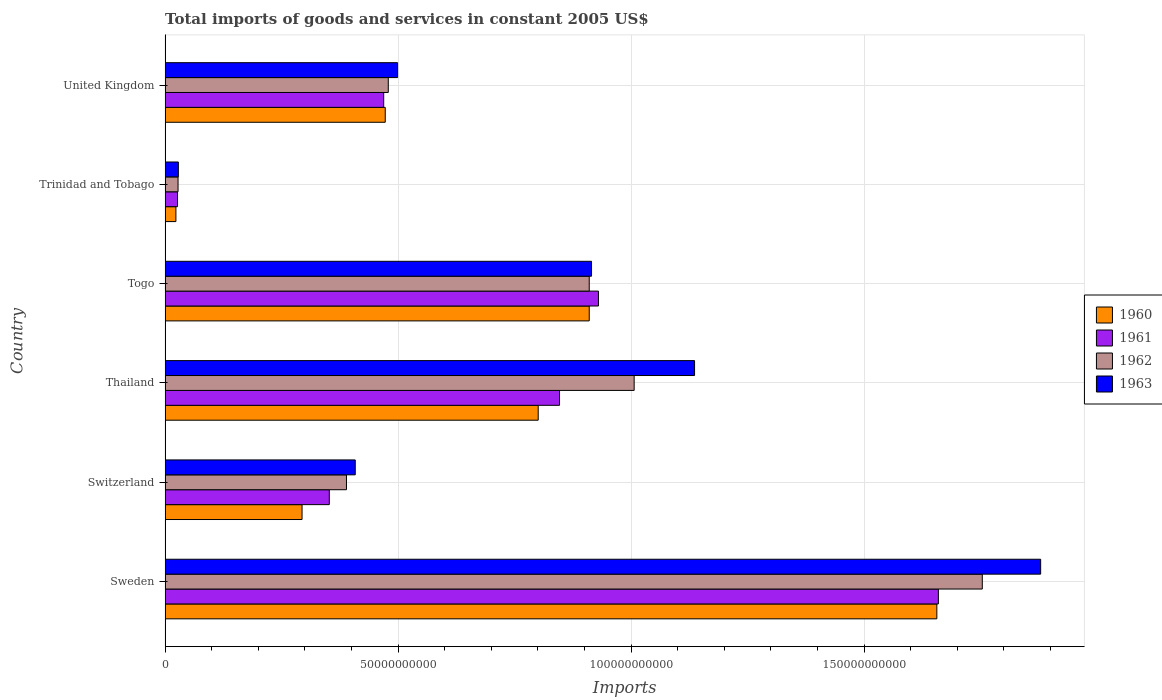How many groups of bars are there?
Offer a terse response. 6. How many bars are there on the 4th tick from the bottom?
Offer a very short reply. 4. What is the label of the 3rd group of bars from the top?
Your answer should be very brief. Togo. In how many cases, is the number of bars for a given country not equal to the number of legend labels?
Your response must be concise. 0. What is the total imports of goods and services in 1961 in Switzerland?
Keep it short and to the point. 3.52e+1. Across all countries, what is the maximum total imports of goods and services in 1963?
Offer a very short reply. 1.88e+11. Across all countries, what is the minimum total imports of goods and services in 1962?
Make the answer very short. 2.78e+09. In which country was the total imports of goods and services in 1960 minimum?
Provide a succinct answer. Trinidad and Tobago. What is the total total imports of goods and services in 1963 in the graph?
Your response must be concise. 4.87e+11. What is the difference between the total imports of goods and services in 1960 in Switzerland and that in Togo?
Provide a short and direct response. -6.16e+1. What is the difference between the total imports of goods and services in 1962 in Thailand and the total imports of goods and services in 1961 in United Kingdom?
Your response must be concise. 5.37e+1. What is the average total imports of goods and services in 1961 per country?
Make the answer very short. 7.14e+1. What is the difference between the total imports of goods and services in 1960 and total imports of goods and services in 1962 in Thailand?
Your answer should be very brief. -2.06e+1. What is the ratio of the total imports of goods and services in 1960 in Switzerland to that in United Kingdom?
Provide a short and direct response. 0.62. Is the difference between the total imports of goods and services in 1960 in Thailand and Trinidad and Tobago greater than the difference between the total imports of goods and services in 1962 in Thailand and Trinidad and Tobago?
Your response must be concise. No. What is the difference between the highest and the second highest total imports of goods and services in 1961?
Your response must be concise. 7.29e+1. What is the difference between the highest and the lowest total imports of goods and services in 1961?
Give a very brief answer. 1.63e+11. Is it the case that in every country, the sum of the total imports of goods and services in 1963 and total imports of goods and services in 1961 is greater than the sum of total imports of goods and services in 1960 and total imports of goods and services in 1962?
Offer a very short reply. No. What does the 2nd bar from the bottom in Togo represents?
Provide a short and direct response. 1961. Are all the bars in the graph horizontal?
Keep it short and to the point. Yes. Are the values on the major ticks of X-axis written in scientific E-notation?
Your answer should be very brief. No. Does the graph contain any zero values?
Make the answer very short. No. Does the graph contain grids?
Give a very brief answer. Yes. How are the legend labels stacked?
Provide a succinct answer. Vertical. What is the title of the graph?
Your answer should be very brief. Total imports of goods and services in constant 2005 US$. Does "1974" appear as one of the legend labels in the graph?
Make the answer very short. No. What is the label or title of the X-axis?
Your answer should be compact. Imports. What is the Imports of 1960 in Sweden?
Your answer should be compact. 1.66e+11. What is the Imports of 1961 in Sweden?
Your answer should be very brief. 1.66e+11. What is the Imports of 1962 in Sweden?
Provide a short and direct response. 1.75e+11. What is the Imports in 1963 in Sweden?
Keep it short and to the point. 1.88e+11. What is the Imports in 1960 in Switzerland?
Offer a very short reply. 2.94e+1. What is the Imports of 1961 in Switzerland?
Your answer should be compact. 3.52e+1. What is the Imports of 1962 in Switzerland?
Provide a succinct answer. 3.89e+1. What is the Imports in 1963 in Switzerland?
Keep it short and to the point. 4.08e+1. What is the Imports in 1960 in Thailand?
Your answer should be compact. 8.01e+1. What is the Imports of 1961 in Thailand?
Your answer should be compact. 8.46e+1. What is the Imports in 1962 in Thailand?
Give a very brief answer. 1.01e+11. What is the Imports in 1963 in Thailand?
Your answer should be very brief. 1.14e+11. What is the Imports in 1960 in Togo?
Provide a short and direct response. 9.10e+1. What is the Imports in 1961 in Togo?
Provide a succinct answer. 9.30e+1. What is the Imports in 1962 in Togo?
Make the answer very short. 9.10e+1. What is the Imports in 1963 in Togo?
Ensure brevity in your answer.  9.15e+1. What is the Imports of 1960 in Trinidad and Tobago?
Ensure brevity in your answer.  2.32e+09. What is the Imports in 1961 in Trinidad and Tobago?
Your response must be concise. 2.67e+09. What is the Imports in 1962 in Trinidad and Tobago?
Keep it short and to the point. 2.78e+09. What is the Imports in 1963 in Trinidad and Tobago?
Offer a terse response. 2.85e+09. What is the Imports of 1960 in United Kingdom?
Your response must be concise. 4.72e+1. What is the Imports in 1961 in United Kingdom?
Your response must be concise. 4.69e+1. What is the Imports in 1962 in United Kingdom?
Offer a terse response. 4.79e+1. What is the Imports in 1963 in United Kingdom?
Give a very brief answer. 4.99e+1. Across all countries, what is the maximum Imports of 1960?
Your response must be concise. 1.66e+11. Across all countries, what is the maximum Imports in 1961?
Offer a very short reply. 1.66e+11. Across all countries, what is the maximum Imports of 1962?
Provide a succinct answer. 1.75e+11. Across all countries, what is the maximum Imports in 1963?
Offer a terse response. 1.88e+11. Across all countries, what is the minimum Imports in 1960?
Provide a short and direct response. 2.32e+09. Across all countries, what is the minimum Imports of 1961?
Ensure brevity in your answer.  2.67e+09. Across all countries, what is the minimum Imports of 1962?
Offer a terse response. 2.78e+09. Across all countries, what is the minimum Imports in 1963?
Keep it short and to the point. 2.85e+09. What is the total Imports of 1960 in the graph?
Keep it short and to the point. 4.16e+11. What is the total Imports in 1961 in the graph?
Your answer should be compact. 4.28e+11. What is the total Imports in 1962 in the graph?
Give a very brief answer. 4.57e+11. What is the total Imports in 1963 in the graph?
Offer a terse response. 4.87e+11. What is the difference between the Imports of 1960 in Sweden and that in Switzerland?
Offer a very short reply. 1.36e+11. What is the difference between the Imports of 1961 in Sweden and that in Switzerland?
Provide a succinct answer. 1.31e+11. What is the difference between the Imports in 1962 in Sweden and that in Switzerland?
Offer a very short reply. 1.36e+11. What is the difference between the Imports of 1963 in Sweden and that in Switzerland?
Make the answer very short. 1.47e+11. What is the difference between the Imports of 1960 in Sweden and that in Thailand?
Offer a very short reply. 8.55e+1. What is the difference between the Imports in 1961 in Sweden and that in Thailand?
Offer a very short reply. 8.13e+1. What is the difference between the Imports in 1962 in Sweden and that in Thailand?
Keep it short and to the point. 7.47e+1. What is the difference between the Imports of 1963 in Sweden and that in Thailand?
Your answer should be compact. 7.43e+1. What is the difference between the Imports in 1960 in Sweden and that in Togo?
Offer a very short reply. 7.46e+1. What is the difference between the Imports of 1961 in Sweden and that in Togo?
Your answer should be compact. 7.29e+1. What is the difference between the Imports of 1962 in Sweden and that in Togo?
Keep it short and to the point. 8.44e+1. What is the difference between the Imports of 1963 in Sweden and that in Togo?
Keep it short and to the point. 9.64e+1. What is the difference between the Imports in 1960 in Sweden and that in Trinidad and Tobago?
Make the answer very short. 1.63e+11. What is the difference between the Imports of 1961 in Sweden and that in Trinidad and Tobago?
Your response must be concise. 1.63e+11. What is the difference between the Imports in 1962 in Sweden and that in Trinidad and Tobago?
Offer a terse response. 1.73e+11. What is the difference between the Imports of 1963 in Sweden and that in Trinidad and Tobago?
Give a very brief answer. 1.85e+11. What is the difference between the Imports of 1960 in Sweden and that in United Kingdom?
Your answer should be compact. 1.18e+11. What is the difference between the Imports in 1961 in Sweden and that in United Kingdom?
Provide a short and direct response. 1.19e+11. What is the difference between the Imports of 1962 in Sweden and that in United Kingdom?
Offer a very short reply. 1.27e+11. What is the difference between the Imports in 1963 in Sweden and that in United Kingdom?
Your response must be concise. 1.38e+11. What is the difference between the Imports in 1960 in Switzerland and that in Thailand?
Keep it short and to the point. -5.07e+1. What is the difference between the Imports of 1961 in Switzerland and that in Thailand?
Make the answer very short. -4.94e+1. What is the difference between the Imports in 1962 in Switzerland and that in Thailand?
Your answer should be compact. -6.17e+1. What is the difference between the Imports in 1963 in Switzerland and that in Thailand?
Offer a terse response. -7.28e+1. What is the difference between the Imports of 1960 in Switzerland and that in Togo?
Give a very brief answer. -6.16e+1. What is the difference between the Imports of 1961 in Switzerland and that in Togo?
Make the answer very short. -5.78e+1. What is the difference between the Imports of 1962 in Switzerland and that in Togo?
Your response must be concise. -5.21e+1. What is the difference between the Imports in 1963 in Switzerland and that in Togo?
Offer a very short reply. -5.07e+1. What is the difference between the Imports of 1960 in Switzerland and that in Trinidad and Tobago?
Provide a short and direct response. 2.71e+1. What is the difference between the Imports of 1961 in Switzerland and that in Trinidad and Tobago?
Your answer should be compact. 3.26e+1. What is the difference between the Imports of 1962 in Switzerland and that in Trinidad and Tobago?
Offer a terse response. 3.61e+1. What is the difference between the Imports of 1963 in Switzerland and that in Trinidad and Tobago?
Provide a short and direct response. 3.80e+1. What is the difference between the Imports of 1960 in Switzerland and that in United Kingdom?
Provide a succinct answer. -1.79e+1. What is the difference between the Imports of 1961 in Switzerland and that in United Kingdom?
Your response must be concise. -1.17e+1. What is the difference between the Imports in 1962 in Switzerland and that in United Kingdom?
Offer a terse response. -8.97e+09. What is the difference between the Imports of 1963 in Switzerland and that in United Kingdom?
Offer a very short reply. -9.09e+09. What is the difference between the Imports in 1960 in Thailand and that in Togo?
Your answer should be compact. -1.09e+1. What is the difference between the Imports of 1961 in Thailand and that in Togo?
Offer a very short reply. -8.35e+09. What is the difference between the Imports in 1962 in Thailand and that in Togo?
Provide a succinct answer. 9.64e+09. What is the difference between the Imports of 1963 in Thailand and that in Togo?
Your answer should be very brief. 2.21e+1. What is the difference between the Imports of 1960 in Thailand and that in Trinidad and Tobago?
Give a very brief answer. 7.77e+1. What is the difference between the Imports of 1961 in Thailand and that in Trinidad and Tobago?
Offer a terse response. 8.20e+1. What is the difference between the Imports of 1962 in Thailand and that in Trinidad and Tobago?
Offer a very short reply. 9.79e+1. What is the difference between the Imports in 1963 in Thailand and that in Trinidad and Tobago?
Keep it short and to the point. 1.11e+11. What is the difference between the Imports in 1960 in Thailand and that in United Kingdom?
Offer a terse response. 3.28e+1. What is the difference between the Imports in 1961 in Thailand and that in United Kingdom?
Offer a terse response. 3.77e+1. What is the difference between the Imports of 1962 in Thailand and that in United Kingdom?
Keep it short and to the point. 5.28e+1. What is the difference between the Imports in 1963 in Thailand and that in United Kingdom?
Keep it short and to the point. 6.37e+1. What is the difference between the Imports of 1960 in Togo and that in Trinidad and Tobago?
Keep it short and to the point. 8.87e+1. What is the difference between the Imports in 1961 in Togo and that in Trinidad and Tobago?
Make the answer very short. 9.03e+1. What is the difference between the Imports of 1962 in Togo and that in Trinidad and Tobago?
Offer a very short reply. 8.82e+1. What is the difference between the Imports of 1963 in Togo and that in Trinidad and Tobago?
Give a very brief answer. 8.87e+1. What is the difference between the Imports in 1960 in Togo and that in United Kingdom?
Give a very brief answer. 4.38e+1. What is the difference between the Imports in 1961 in Togo and that in United Kingdom?
Ensure brevity in your answer.  4.61e+1. What is the difference between the Imports of 1962 in Togo and that in United Kingdom?
Provide a short and direct response. 4.31e+1. What is the difference between the Imports in 1963 in Togo and that in United Kingdom?
Your answer should be compact. 4.16e+1. What is the difference between the Imports of 1960 in Trinidad and Tobago and that in United Kingdom?
Offer a very short reply. -4.49e+1. What is the difference between the Imports of 1961 in Trinidad and Tobago and that in United Kingdom?
Your answer should be compact. -4.42e+1. What is the difference between the Imports in 1962 in Trinidad and Tobago and that in United Kingdom?
Provide a succinct answer. -4.51e+1. What is the difference between the Imports of 1963 in Trinidad and Tobago and that in United Kingdom?
Give a very brief answer. -4.70e+1. What is the difference between the Imports of 1960 in Sweden and the Imports of 1961 in Switzerland?
Offer a terse response. 1.30e+11. What is the difference between the Imports of 1960 in Sweden and the Imports of 1962 in Switzerland?
Your answer should be compact. 1.27e+11. What is the difference between the Imports in 1960 in Sweden and the Imports in 1963 in Switzerland?
Offer a terse response. 1.25e+11. What is the difference between the Imports in 1961 in Sweden and the Imports in 1962 in Switzerland?
Your answer should be compact. 1.27e+11. What is the difference between the Imports of 1961 in Sweden and the Imports of 1963 in Switzerland?
Provide a short and direct response. 1.25e+11. What is the difference between the Imports of 1962 in Sweden and the Imports of 1963 in Switzerland?
Your answer should be very brief. 1.35e+11. What is the difference between the Imports in 1960 in Sweden and the Imports in 1961 in Thailand?
Ensure brevity in your answer.  8.10e+1. What is the difference between the Imports in 1960 in Sweden and the Imports in 1962 in Thailand?
Your answer should be very brief. 6.50e+1. What is the difference between the Imports of 1960 in Sweden and the Imports of 1963 in Thailand?
Ensure brevity in your answer.  5.20e+1. What is the difference between the Imports of 1961 in Sweden and the Imports of 1962 in Thailand?
Your answer should be very brief. 6.53e+1. What is the difference between the Imports in 1961 in Sweden and the Imports in 1963 in Thailand?
Offer a very short reply. 5.23e+1. What is the difference between the Imports of 1962 in Sweden and the Imports of 1963 in Thailand?
Offer a very short reply. 6.17e+1. What is the difference between the Imports of 1960 in Sweden and the Imports of 1961 in Togo?
Give a very brief answer. 7.26e+1. What is the difference between the Imports in 1960 in Sweden and the Imports in 1962 in Togo?
Offer a very short reply. 7.46e+1. What is the difference between the Imports of 1960 in Sweden and the Imports of 1963 in Togo?
Make the answer very short. 7.41e+1. What is the difference between the Imports in 1961 in Sweden and the Imports in 1962 in Togo?
Your answer should be very brief. 7.49e+1. What is the difference between the Imports in 1961 in Sweden and the Imports in 1963 in Togo?
Keep it short and to the point. 7.44e+1. What is the difference between the Imports in 1962 in Sweden and the Imports in 1963 in Togo?
Keep it short and to the point. 8.39e+1. What is the difference between the Imports in 1960 in Sweden and the Imports in 1961 in Trinidad and Tobago?
Your response must be concise. 1.63e+11. What is the difference between the Imports in 1960 in Sweden and the Imports in 1962 in Trinidad and Tobago?
Provide a succinct answer. 1.63e+11. What is the difference between the Imports in 1960 in Sweden and the Imports in 1963 in Trinidad and Tobago?
Offer a very short reply. 1.63e+11. What is the difference between the Imports in 1961 in Sweden and the Imports in 1962 in Trinidad and Tobago?
Provide a succinct answer. 1.63e+11. What is the difference between the Imports in 1961 in Sweden and the Imports in 1963 in Trinidad and Tobago?
Ensure brevity in your answer.  1.63e+11. What is the difference between the Imports in 1962 in Sweden and the Imports in 1963 in Trinidad and Tobago?
Provide a succinct answer. 1.73e+11. What is the difference between the Imports of 1960 in Sweden and the Imports of 1961 in United Kingdom?
Provide a short and direct response. 1.19e+11. What is the difference between the Imports of 1960 in Sweden and the Imports of 1962 in United Kingdom?
Offer a very short reply. 1.18e+11. What is the difference between the Imports in 1960 in Sweden and the Imports in 1963 in United Kingdom?
Your answer should be compact. 1.16e+11. What is the difference between the Imports of 1961 in Sweden and the Imports of 1962 in United Kingdom?
Offer a terse response. 1.18e+11. What is the difference between the Imports of 1961 in Sweden and the Imports of 1963 in United Kingdom?
Offer a very short reply. 1.16e+11. What is the difference between the Imports of 1962 in Sweden and the Imports of 1963 in United Kingdom?
Make the answer very short. 1.25e+11. What is the difference between the Imports of 1960 in Switzerland and the Imports of 1961 in Thailand?
Your answer should be very brief. -5.53e+1. What is the difference between the Imports of 1960 in Switzerland and the Imports of 1962 in Thailand?
Your answer should be very brief. -7.13e+1. What is the difference between the Imports of 1960 in Switzerland and the Imports of 1963 in Thailand?
Make the answer very short. -8.42e+1. What is the difference between the Imports in 1961 in Switzerland and the Imports in 1962 in Thailand?
Your answer should be compact. -6.54e+1. What is the difference between the Imports of 1961 in Switzerland and the Imports of 1963 in Thailand?
Your response must be concise. -7.84e+1. What is the difference between the Imports in 1962 in Switzerland and the Imports in 1963 in Thailand?
Your answer should be compact. -7.47e+1. What is the difference between the Imports of 1960 in Switzerland and the Imports of 1961 in Togo?
Provide a succinct answer. -6.36e+1. What is the difference between the Imports of 1960 in Switzerland and the Imports of 1962 in Togo?
Your answer should be very brief. -6.16e+1. What is the difference between the Imports of 1960 in Switzerland and the Imports of 1963 in Togo?
Your answer should be compact. -6.21e+1. What is the difference between the Imports in 1961 in Switzerland and the Imports in 1962 in Togo?
Your response must be concise. -5.58e+1. What is the difference between the Imports of 1961 in Switzerland and the Imports of 1963 in Togo?
Your answer should be very brief. -5.63e+1. What is the difference between the Imports in 1962 in Switzerland and the Imports in 1963 in Togo?
Provide a short and direct response. -5.26e+1. What is the difference between the Imports of 1960 in Switzerland and the Imports of 1961 in Trinidad and Tobago?
Ensure brevity in your answer.  2.67e+1. What is the difference between the Imports of 1960 in Switzerland and the Imports of 1962 in Trinidad and Tobago?
Provide a short and direct response. 2.66e+1. What is the difference between the Imports of 1960 in Switzerland and the Imports of 1963 in Trinidad and Tobago?
Give a very brief answer. 2.65e+1. What is the difference between the Imports in 1961 in Switzerland and the Imports in 1962 in Trinidad and Tobago?
Offer a terse response. 3.25e+1. What is the difference between the Imports of 1961 in Switzerland and the Imports of 1963 in Trinidad and Tobago?
Offer a terse response. 3.24e+1. What is the difference between the Imports of 1962 in Switzerland and the Imports of 1963 in Trinidad and Tobago?
Offer a terse response. 3.61e+1. What is the difference between the Imports in 1960 in Switzerland and the Imports in 1961 in United Kingdom?
Offer a terse response. -1.75e+1. What is the difference between the Imports of 1960 in Switzerland and the Imports of 1962 in United Kingdom?
Offer a very short reply. -1.85e+1. What is the difference between the Imports in 1960 in Switzerland and the Imports in 1963 in United Kingdom?
Give a very brief answer. -2.05e+1. What is the difference between the Imports of 1961 in Switzerland and the Imports of 1962 in United Kingdom?
Your answer should be very brief. -1.27e+1. What is the difference between the Imports of 1961 in Switzerland and the Imports of 1963 in United Kingdom?
Your answer should be very brief. -1.47e+1. What is the difference between the Imports in 1962 in Switzerland and the Imports in 1963 in United Kingdom?
Provide a short and direct response. -1.10e+1. What is the difference between the Imports in 1960 in Thailand and the Imports in 1961 in Togo?
Provide a short and direct response. -1.29e+1. What is the difference between the Imports in 1960 in Thailand and the Imports in 1962 in Togo?
Your answer should be very brief. -1.09e+1. What is the difference between the Imports of 1960 in Thailand and the Imports of 1963 in Togo?
Offer a terse response. -1.14e+1. What is the difference between the Imports in 1961 in Thailand and the Imports in 1962 in Togo?
Your response must be concise. -6.37e+09. What is the difference between the Imports of 1961 in Thailand and the Imports of 1963 in Togo?
Ensure brevity in your answer.  -6.87e+09. What is the difference between the Imports of 1962 in Thailand and the Imports of 1963 in Togo?
Your response must be concise. 9.15e+09. What is the difference between the Imports of 1960 in Thailand and the Imports of 1961 in Trinidad and Tobago?
Offer a very short reply. 7.74e+1. What is the difference between the Imports of 1960 in Thailand and the Imports of 1962 in Trinidad and Tobago?
Keep it short and to the point. 7.73e+1. What is the difference between the Imports in 1960 in Thailand and the Imports in 1963 in Trinidad and Tobago?
Ensure brevity in your answer.  7.72e+1. What is the difference between the Imports in 1961 in Thailand and the Imports in 1962 in Trinidad and Tobago?
Your answer should be compact. 8.19e+1. What is the difference between the Imports in 1961 in Thailand and the Imports in 1963 in Trinidad and Tobago?
Your answer should be very brief. 8.18e+1. What is the difference between the Imports of 1962 in Thailand and the Imports of 1963 in Trinidad and Tobago?
Give a very brief answer. 9.78e+1. What is the difference between the Imports in 1960 in Thailand and the Imports in 1961 in United Kingdom?
Provide a short and direct response. 3.32e+1. What is the difference between the Imports of 1960 in Thailand and the Imports of 1962 in United Kingdom?
Your response must be concise. 3.22e+1. What is the difference between the Imports in 1960 in Thailand and the Imports in 1963 in United Kingdom?
Your response must be concise. 3.02e+1. What is the difference between the Imports in 1961 in Thailand and the Imports in 1962 in United Kingdom?
Keep it short and to the point. 3.68e+1. What is the difference between the Imports of 1961 in Thailand and the Imports of 1963 in United Kingdom?
Provide a short and direct response. 3.48e+1. What is the difference between the Imports in 1962 in Thailand and the Imports in 1963 in United Kingdom?
Make the answer very short. 5.08e+1. What is the difference between the Imports of 1960 in Togo and the Imports of 1961 in Trinidad and Tobago?
Offer a terse response. 8.84e+1. What is the difference between the Imports in 1960 in Togo and the Imports in 1962 in Trinidad and Tobago?
Make the answer very short. 8.82e+1. What is the difference between the Imports of 1960 in Togo and the Imports of 1963 in Trinidad and Tobago?
Your answer should be compact. 8.82e+1. What is the difference between the Imports of 1961 in Togo and the Imports of 1962 in Trinidad and Tobago?
Provide a succinct answer. 9.02e+1. What is the difference between the Imports of 1961 in Togo and the Imports of 1963 in Trinidad and Tobago?
Provide a short and direct response. 9.02e+1. What is the difference between the Imports of 1962 in Togo and the Imports of 1963 in Trinidad and Tobago?
Offer a terse response. 8.82e+1. What is the difference between the Imports in 1960 in Togo and the Imports in 1961 in United Kingdom?
Keep it short and to the point. 4.41e+1. What is the difference between the Imports in 1960 in Togo and the Imports in 1962 in United Kingdom?
Provide a short and direct response. 4.31e+1. What is the difference between the Imports in 1960 in Togo and the Imports in 1963 in United Kingdom?
Your answer should be very brief. 4.11e+1. What is the difference between the Imports in 1961 in Togo and the Imports in 1962 in United Kingdom?
Offer a terse response. 4.51e+1. What is the difference between the Imports in 1961 in Togo and the Imports in 1963 in United Kingdom?
Ensure brevity in your answer.  4.31e+1. What is the difference between the Imports of 1962 in Togo and the Imports of 1963 in United Kingdom?
Your response must be concise. 4.11e+1. What is the difference between the Imports in 1960 in Trinidad and Tobago and the Imports in 1961 in United Kingdom?
Keep it short and to the point. -4.46e+1. What is the difference between the Imports in 1960 in Trinidad and Tobago and the Imports in 1962 in United Kingdom?
Offer a terse response. -4.56e+1. What is the difference between the Imports of 1960 in Trinidad and Tobago and the Imports of 1963 in United Kingdom?
Offer a terse response. -4.76e+1. What is the difference between the Imports of 1961 in Trinidad and Tobago and the Imports of 1962 in United Kingdom?
Offer a terse response. -4.52e+1. What is the difference between the Imports of 1961 in Trinidad and Tobago and the Imports of 1963 in United Kingdom?
Your answer should be compact. -4.72e+1. What is the difference between the Imports of 1962 in Trinidad and Tobago and the Imports of 1963 in United Kingdom?
Your answer should be very brief. -4.71e+1. What is the average Imports of 1960 per country?
Make the answer very short. 6.93e+1. What is the average Imports of 1961 per country?
Your answer should be compact. 7.14e+1. What is the average Imports in 1962 per country?
Provide a short and direct response. 7.61e+1. What is the average Imports in 1963 per country?
Offer a very short reply. 8.11e+1. What is the difference between the Imports of 1960 and Imports of 1961 in Sweden?
Keep it short and to the point. -3.29e+08. What is the difference between the Imports in 1960 and Imports in 1962 in Sweden?
Make the answer very short. -9.75e+09. What is the difference between the Imports in 1960 and Imports in 1963 in Sweden?
Ensure brevity in your answer.  -2.23e+1. What is the difference between the Imports of 1961 and Imports of 1962 in Sweden?
Offer a terse response. -9.42e+09. What is the difference between the Imports of 1961 and Imports of 1963 in Sweden?
Provide a short and direct response. -2.19e+1. What is the difference between the Imports in 1962 and Imports in 1963 in Sweden?
Keep it short and to the point. -1.25e+1. What is the difference between the Imports in 1960 and Imports in 1961 in Switzerland?
Your response must be concise. -5.85e+09. What is the difference between the Imports of 1960 and Imports of 1962 in Switzerland?
Offer a terse response. -9.53e+09. What is the difference between the Imports in 1960 and Imports in 1963 in Switzerland?
Your response must be concise. -1.14e+1. What is the difference between the Imports of 1961 and Imports of 1962 in Switzerland?
Ensure brevity in your answer.  -3.69e+09. What is the difference between the Imports of 1961 and Imports of 1963 in Switzerland?
Make the answer very short. -5.57e+09. What is the difference between the Imports of 1962 and Imports of 1963 in Switzerland?
Provide a short and direct response. -1.88e+09. What is the difference between the Imports of 1960 and Imports of 1961 in Thailand?
Ensure brevity in your answer.  -4.58e+09. What is the difference between the Imports of 1960 and Imports of 1962 in Thailand?
Offer a very short reply. -2.06e+1. What is the difference between the Imports in 1960 and Imports in 1963 in Thailand?
Ensure brevity in your answer.  -3.36e+1. What is the difference between the Imports in 1961 and Imports in 1962 in Thailand?
Provide a succinct answer. -1.60e+1. What is the difference between the Imports of 1961 and Imports of 1963 in Thailand?
Keep it short and to the point. -2.90e+1. What is the difference between the Imports of 1962 and Imports of 1963 in Thailand?
Provide a short and direct response. -1.30e+1. What is the difference between the Imports of 1960 and Imports of 1961 in Togo?
Make the answer very short. -1.98e+09. What is the difference between the Imports in 1960 and Imports in 1963 in Togo?
Ensure brevity in your answer.  -4.94e+08. What is the difference between the Imports in 1961 and Imports in 1962 in Togo?
Provide a succinct answer. 1.98e+09. What is the difference between the Imports in 1961 and Imports in 1963 in Togo?
Give a very brief answer. 1.48e+09. What is the difference between the Imports of 1962 and Imports of 1963 in Togo?
Make the answer very short. -4.94e+08. What is the difference between the Imports of 1960 and Imports of 1961 in Trinidad and Tobago?
Offer a very short reply. -3.48e+08. What is the difference between the Imports in 1960 and Imports in 1962 in Trinidad and Tobago?
Your answer should be very brief. -4.60e+08. What is the difference between the Imports of 1960 and Imports of 1963 in Trinidad and Tobago?
Provide a short and direct response. -5.24e+08. What is the difference between the Imports in 1961 and Imports in 1962 in Trinidad and Tobago?
Provide a short and direct response. -1.12e+08. What is the difference between the Imports in 1961 and Imports in 1963 in Trinidad and Tobago?
Your answer should be very brief. -1.77e+08. What is the difference between the Imports of 1962 and Imports of 1963 in Trinidad and Tobago?
Keep it short and to the point. -6.48e+07. What is the difference between the Imports in 1960 and Imports in 1961 in United Kingdom?
Keep it short and to the point. 3.32e+08. What is the difference between the Imports of 1960 and Imports of 1962 in United Kingdom?
Make the answer very short. -6.50e+08. What is the difference between the Imports in 1960 and Imports in 1963 in United Kingdom?
Make the answer very short. -2.65e+09. What is the difference between the Imports of 1961 and Imports of 1962 in United Kingdom?
Provide a short and direct response. -9.83e+08. What is the difference between the Imports in 1961 and Imports in 1963 in United Kingdom?
Offer a terse response. -2.98e+09. What is the difference between the Imports of 1962 and Imports of 1963 in United Kingdom?
Your response must be concise. -2.00e+09. What is the ratio of the Imports of 1960 in Sweden to that in Switzerland?
Offer a terse response. 5.64. What is the ratio of the Imports of 1961 in Sweden to that in Switzerland?
Offer a terse response. 4.71. What is the ratio of the Imports in 1962 in Sweden to that in Switzerland?
Keep it short and to the point. 4.51. What is the ratio of the Imports in 1963 in Sweden to that in Switzerland?
Give a very brief answer. 4.6. What is the ratio of the Imports of 1960 in Sweden to that in Thailand?
Provide a short and direct response. 2.07. What is the ratio of the Imports in 1961 in Sweden to that in Thailand?
Your response must be concise. 1.96. What is the ratio of the Imports of 1962 in Sweden to that in Thailand?
Your answer should be very brief. 1.74. What is the ratio of the Imports of 1963 in Sweden to that in Thailand?
Your answer should be very brief. 1.65. What is the ratio of the Imports of 1960 in Sweden to that in Togo?
Provide a succinct answer. 1.82. What is the ratio of the Imports of 1961 in Sweden to that in Togo?
Provide a succinct answer. 1.78. What is the ratio of the Imports of 1962 in Sweden to that in Togo?
Offer a terse response. 1.93. What is the ratio of the Imports in 1963 in Sweden to that in Togo?
Offer a very short reply. 2.05. What is the ratio of the Imports in 1960 in Sweden to that in Trinidad and Tobago?
Offer a terse response. 71.35. What is the ratio of the Imports of 1961 in Sweden to that in Trinidad and Tobago?
Your answer should be compact. 62.18. What is the ratio of the Imports in 1962 in Sweden to that in Trinidad and Tobago?
Provide a short and direct response. 63.07. What is the ratio of the Imports in 1963 in Sweden to that in Trinidad and Tobago?
Your answer should be compact. 66.04. What is the ratio of the Imports in 1960 in Sweden to that in United Kingdom?
Make the answer very short. 3.51. What is the ratio of the Imports in 1961 in Sweden to that in United Kingdom?
Offer a very short reply. 3.54. What is the ratio of the Imports in 1962 in Sweden to that in United Kingdom?
Offer a very short reply. 3.66. What is the ratio of the Imports of 1963 in Sweden to that in United Kingdom?
Give a very brief answer. 3.77. What is the ratio of the Imports of 1960 in Switzerland to that in Thailand?
Give a very brief answer. 0.37. What is the ratio of the Imports in 1961 in Switzerland to that in Thailand?
Offer a very short reply. 0.42. What is the ratio of the Imports of 1962 in Switzerland to that in Thailand?
Keep it short and to the point. 0.39. What is the ratio of the Imports in 1963 in Switzerland to that in Thailand?
Offer a terse response. 0.36. What is the ratio of the Imports in 1960 in Switzerland to that in Togo?
Provide a succinct answer. 0.32. What is the ratio of the Imports of 1961 in Switzerland to that in Togo?
Keep it short and to the point. 0.38. What is the ratio of the Imports in 1962 in Switzerland to that in Togo?
Provide a succinct answer. 0.43. What is the ratio of the Imports of 1963 in Switzerland to that in Togo?
Offer a terse response. 0.45. What is the ratio of the Imports of 1960 in Switzerland to that in Trinidad and Tobago?
Provide a succinct answer. 12.66. What is the ratio of the Imports of 1961 in Switzerland to that in Trinidad and Tobago?
Provide a short and direct response. 13.2. What is the ratio of the Imports in 1962 in Switzerland to that in Trinidad and Tobago?
Offer a very short reply. 14. What is the ratio of the Imports of 1963 in Switzerland to that in Trinidad and Tobago?
Your answer should be very brief. 14.34. What is the ratio of the Imports in 1960 in Switzerland to that in United Kingdom?
Offer a terse response. 0.62. What is the ratio of the Imports in 1961 in Switzerland to that in United Kingdom?
Provide a succinct answer. 0.75. What is the ratio of the Imports of 1962 in Switzerland to that in United Kingdom?
Offer a terse response. 0.81. What is the ratio of the Imports in 1963 in Switzerland to that in United Kingdom?
Your answer should be very brief. 0.82. What is the ratio of the Imports in 1960 in Thailand to that in Togo?
Provide a short and direct response. 0.88. What is the ratio of the Imports of 1961 in Thailand to that in Togo?
Provide a succinct answer. 0.91. What is the ratio of the Imports in 1962 in Thailand to that in Togo?
Offer a terse response. 1.11. What is the ratio of the Imports in 1963 in Thailand to that in Togo?
Your response must be concise. 1.24. What is the ratio of the Imports in 1960 in Thailand to that in Trinidad and Tobago?
Your answer should be compact. 34.5. What is the ratio of the Imports in 1961 in Thailand to that in Trinidad and Tobago?
Your answer should be very brief. 31.72. What is the ratio of the Imports of 1962 in Thailand to that in Trinidad and Tobago?
Make the answer very short. 36.2. What is the ratio of the Imports in 1963 in Thailand to that in Trinidad and Tobago?
Keep it short and to the point. 39.93. What is the ratio of the Imports of 1960 in Thailand to that in United Kingdom?
Ensure brevity in your answer.  1.69. What is the ratio of the Imports in 1961 in Thailand to that in United Kingdom?
Your response must be concise. 1.8. What is the ratio of the Imports of 1962 in Thailand to that in United Kingdom?
Provide a succinct answer. 2.1. What is the ratio of the Imports of 1963 in Thailand to that in United Kingdom?
Ensure brevity in your answer.  2.28. What is the ratio of the Imports of 1960 in Togo to that in Trinidad and Tobago?
Ensure brevity in your answer.  39.21. What is the ratio of the Imports in 1961 in Togo to that in Trinidad and Tobago?
Keep it short and to the point. 34.85. What is the ratio of the Imports in 1962 in Togo to that in Trinidad and Tobago?
Your answer should be compact. 32.73. What is the ratio of the Imports of 1963 in Togo to that in Trinidad and Tobago?
Offer a terse response. 32.16. What is the ratio of the Imports in 1960 in Togo to that in United Kingdom?
Your response must be concise. 1.93. What is the ratio of the Imports in 1961 in Togo to that in United Kingdom?
Keep it short and to the point. 1.98. What is the ratio of the Imports in 1962 in Togo to that in United Kingdom?
Give a very brief answer. 1.9. What is the ratio of the Imports in 1963 in Togo to that in United Kingdom?
Your answer should be very brief. 1.83. What is the ratio of the Imports in 1960 in Trinidad and Tobago to that in United Kingdom?
Your answer should be very brief. 0.05. What is the ratio of the Imports in 1961 in Trinidad and Tobago to that in United Kingdom?
Your response must be concise. 0.06. What is the ratio of the Imports of 1962 in Trinidad and Tobago to that in United Kingdom?
Provide a succinct answer. 0.06. What is the ratio of the Imports of 1963 in Trinidad and Tobago to that in United Kingdom?
Your answer should be compact. 0.06. What is the difference between the highest and the second highest Imports of 1960?
Provide a succinct answer. 7.46e+1. What is the difference between the highest and the second highest Imports in 1961?
Give a very brief answer. 7.29e+1. What is the difference between the highest and the second highest Imports in 1962?
Offer a very short reply. 7.47e+1. What is the difference between the highest and the second highest Imports in 1963?
Make the answer very short. 7.43e+1. What is the difference between the highest and the lowest Imports in 1960?
Provide a succinct answer. 1.63e+11. What is the difference between the highest and the lowest Imports of 1961?
Ensure brevity in your answer.  1.63e+11. What is the difference between the highest and the lowest Imports in 1962?
Your answer should be compact. 1.73e+11. What is the difference between the highest and the lowest Imports in 1963?
Provide a succinct answer. 1.85e+11. 